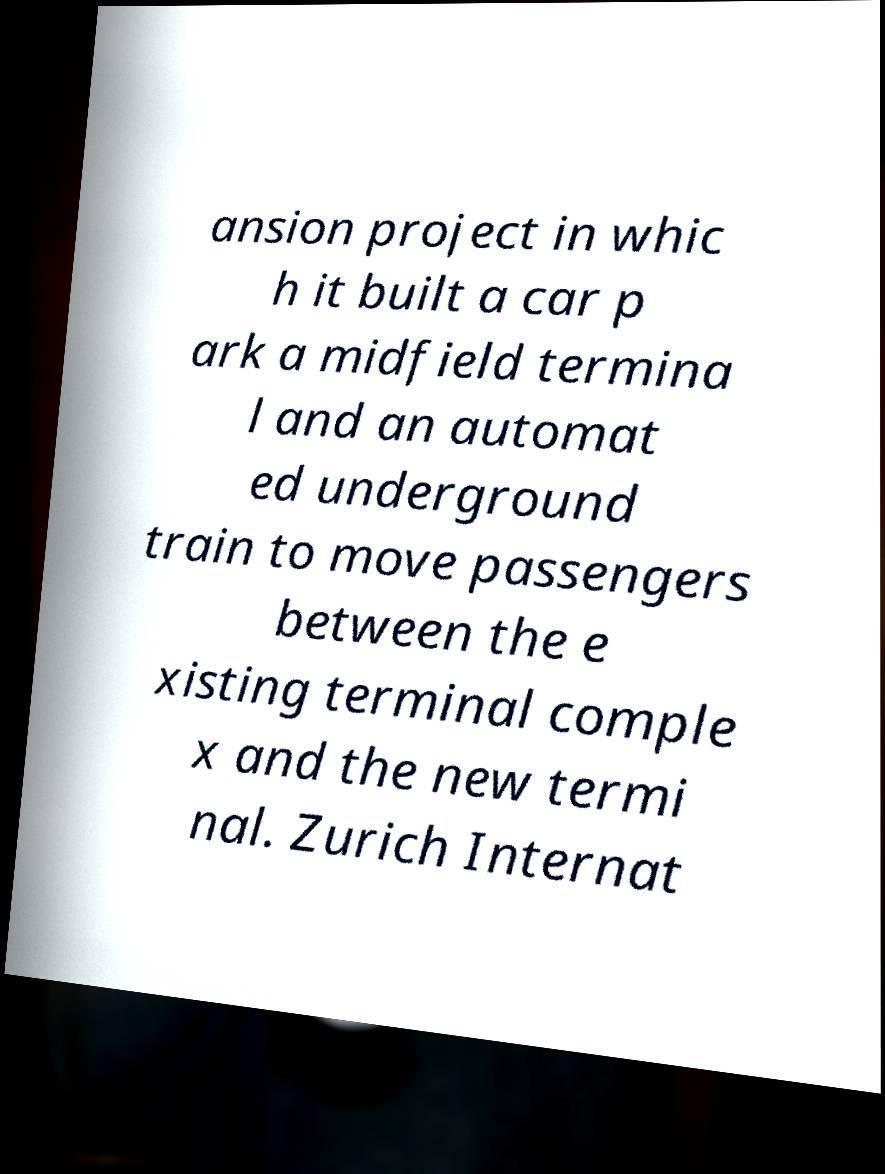I need the written content from this picture converted into text. Can you do that? ansion project in whic h it built a car p ark a midfield termina l and an automat ed underground train to move passengers between the e xisting terminal comple x and the new termi nal. Zurich Internat 